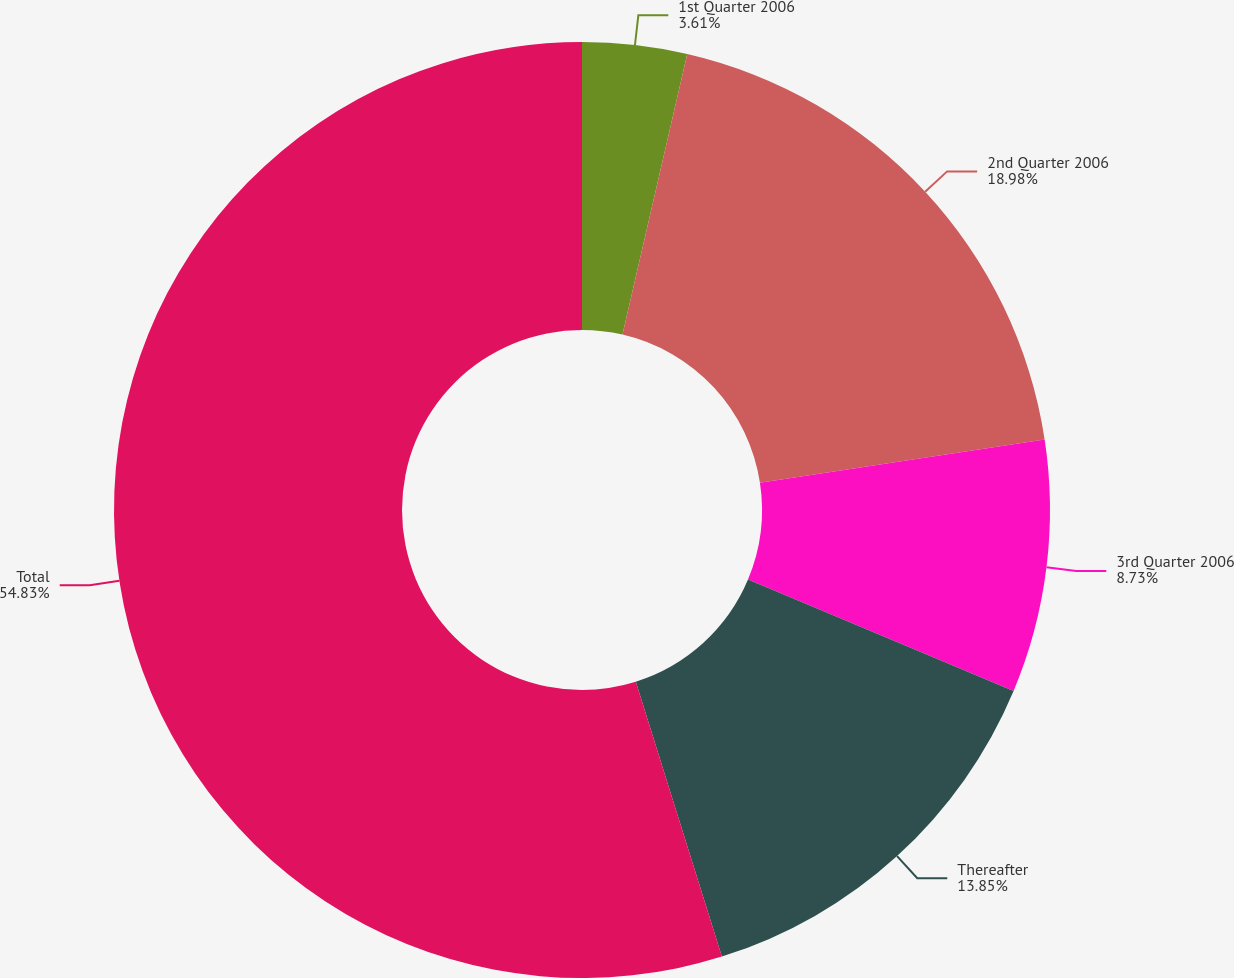<chart> <loc_0><loc_0><loc_500><loc_500><pie_chart><fcel>1st Quarter 2006<fcel>2nd Quarter 2006<fcel>3rd Quarter 2006<fcel>Thereafter<fcel>Total<nl><fcel>3.61%<fcel>18.98%<fcel>8.73%<fcel>13.85%<fcel>54.83%<nl></chart> 